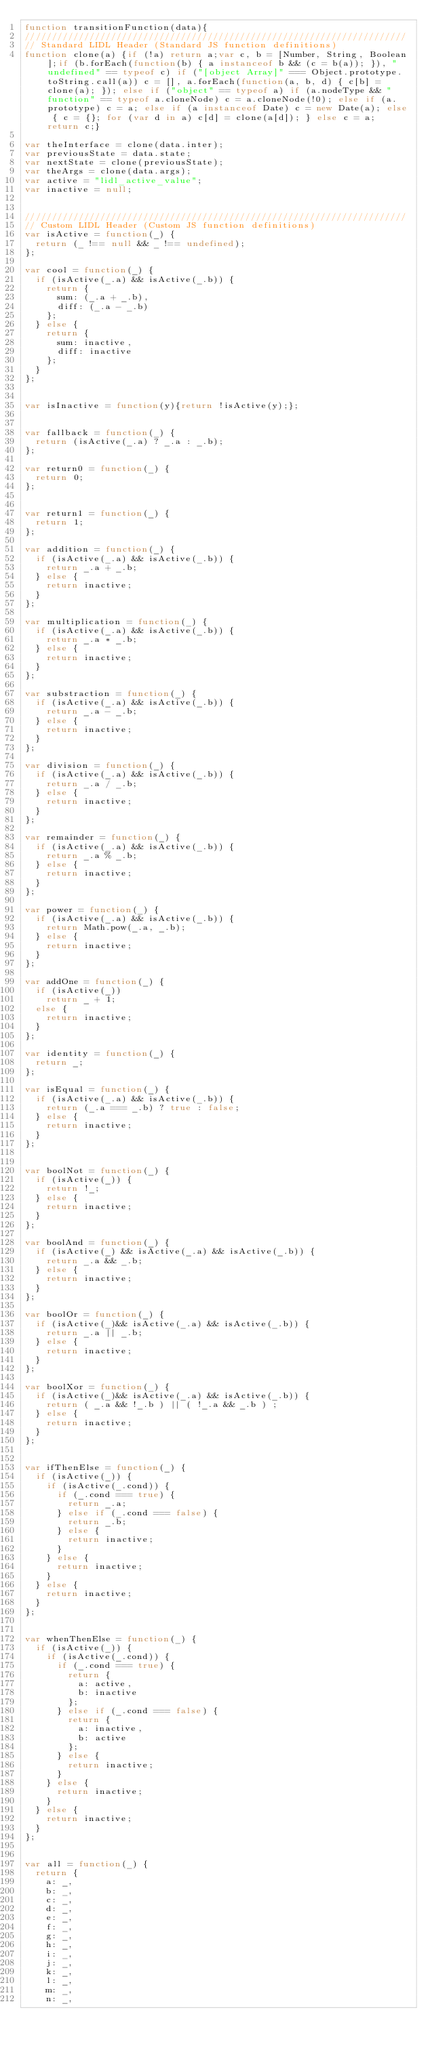<code> <loc_0><loc_0><loc_500><loc_500><_JavaScript_>function transitionFunction(data){
///////////////////////////////////////////////////////////////////////
// Standard LIDL Header (Standard JS function definitions)
function clone(a) {if (!a) return a;var c, b = [Number, String, Boolean];if (b.forEach(function(b) { a instanceof b && (c = b(a)); }), "undefined" == typeof c) if ("[object Array]" === Object.prototype.toString.call(a)) c = [], a.forEach(function(a, b, d) { c[b] = clone(a); }); else if ("object" == typeof a) if (a.nodeType && "function" == typeof a.cloneNode) c = a.cloneNode(!0); else if (a.prototype) c = a; else if (a instanceof Date) c = new Date(a); else { c = {}; for (var d in a) c[d] = clone(a[d]); } else c = a; return c;}

var theInterface = clone(data.inter);
var previousState = data.state;
var nextState = clone(previousState);
var theArgs = clone(data.args);
var active = "lidl_active_value";
var inactive = null;


///////////////////////////////////////////////////////////////////////
// Custom LIDL Header (Custom JS function definitions)
var isActive = function(_) {
  return (_ !== null && _ !== undefined);
};

var cool = function(_) {
  if (isActive(_.a) && isActive(_.b)) {
    return {
      sum: (_.a + _.b),
      diff: (_.a - _.b)
    };
  } else {
    return {
      sum: inactive,
      diff: inactive
    };
  }
};


var isInactive = function(y){return !isActive(y);};


var fallback = function(_) {
  return (isActive(_.a) ? _.a : _.b);
};

var return0 = function(_) {
  return 0;
};


var return1 = function(_) {
  return 1;
};

var addition = function(_) {
  if (isActive(_.a) && isActive(_.b)) {
    return _.a + _.b;
  } else {
    return inactive;
  }
};

var multiplication = function(_) {
  if (isActive(_.a) && isActive(_.b)) {
    return _.a * _.b;
  } else {
    return inactive;
  }
};

var substraction = function(_) {
  if (isActive(_.a) && isActive(_.b)) {
    return _.a - _.b;
  } else {
    return inactive;
  }
};

var division = function(_) {
  if (isActive(_.a) && isActive(_.b)) {
    return _.a / _.b;
  } else {
    return inactive;
  }
};

var remainder = function(_) {
  if (isActive(_.a) && isActive(_.b)) {
    return _.a % _.b;
  } else {
    return inactive;
  }
};

var power = function(_) {
  if (isActive(_.a) && isActive(_.b)) {
    return Math.pow(_.a, _.b);
  } else {
    return inactive;
  }
};

var addOne = function(_) {
  if (isActive(_))
    return _ + 1;
  else {
    return inactive;
  }
};

var identity = function(_) {
  return _;
};

var isEqual = function(_) {
  if (isActive(_.a) && isActive(_.b)) {
    return (_.a === _.b) ? true : false;
  } else {
    return inactive;
  }
};


var boolNot = function(_) {
  if (isActive(_)) {
    return !_;
  } else {
    return inactive;
  }
};

var boolAnd = function(_) {
  if (isActive(_) && isActive(_.a) && isActive(_.b)) {
    return _.a && _.b;
  } else {
    return inactive;
  }
};

var boolOr = function(_) {
  if (isActive(_)&& isActive(_.a) && isActive(_.b)) {
    return _.a || _.b;
  } else {
    return inactive;
  }
};

var boolXor = function(_) {
  if (isActive(_)&& isActive(_.a) && isActive(_.b)) {
    return ( _.a && !_.b ) || ( !_.a && _.b ) ;
  } else {
    return inactive;
  }
};


var ifThenElse = function(_) {
  if (isActive(_)) {
    if (isActive(_.cond)) {
      if (_.cond === true) {
        return _.a;
      } else if (_.cond === false) {
        return _.b;
      } else {
        return inactive;
      }
    } else {
      return inactive;
    }
  } else {
    return inactive;
  }
};


var whenThenElse = function(_) {
  if (isActive(_)) {
    if (isActive(_.cond)) {
      if (_.cond === true) {
        return {
          a: active,
          b: inactive
        };
      } else if (_.cond === false) {
        return {
          a: inactive,
          b: active
        };
      } else {
        return inactive;
      }
    } else {
      return inactive;
    }
  } else {
    return inactive;
  }
};


var all = function(_) {
  return {
    a: _,
    b: _,
    c: _,
    d: _,
    e: _,
    f: _,
    g: _,
    h: _,
    i: _,
    j: _,
    k: _,
    l: _,
    m: _,
    n: _,</code> 